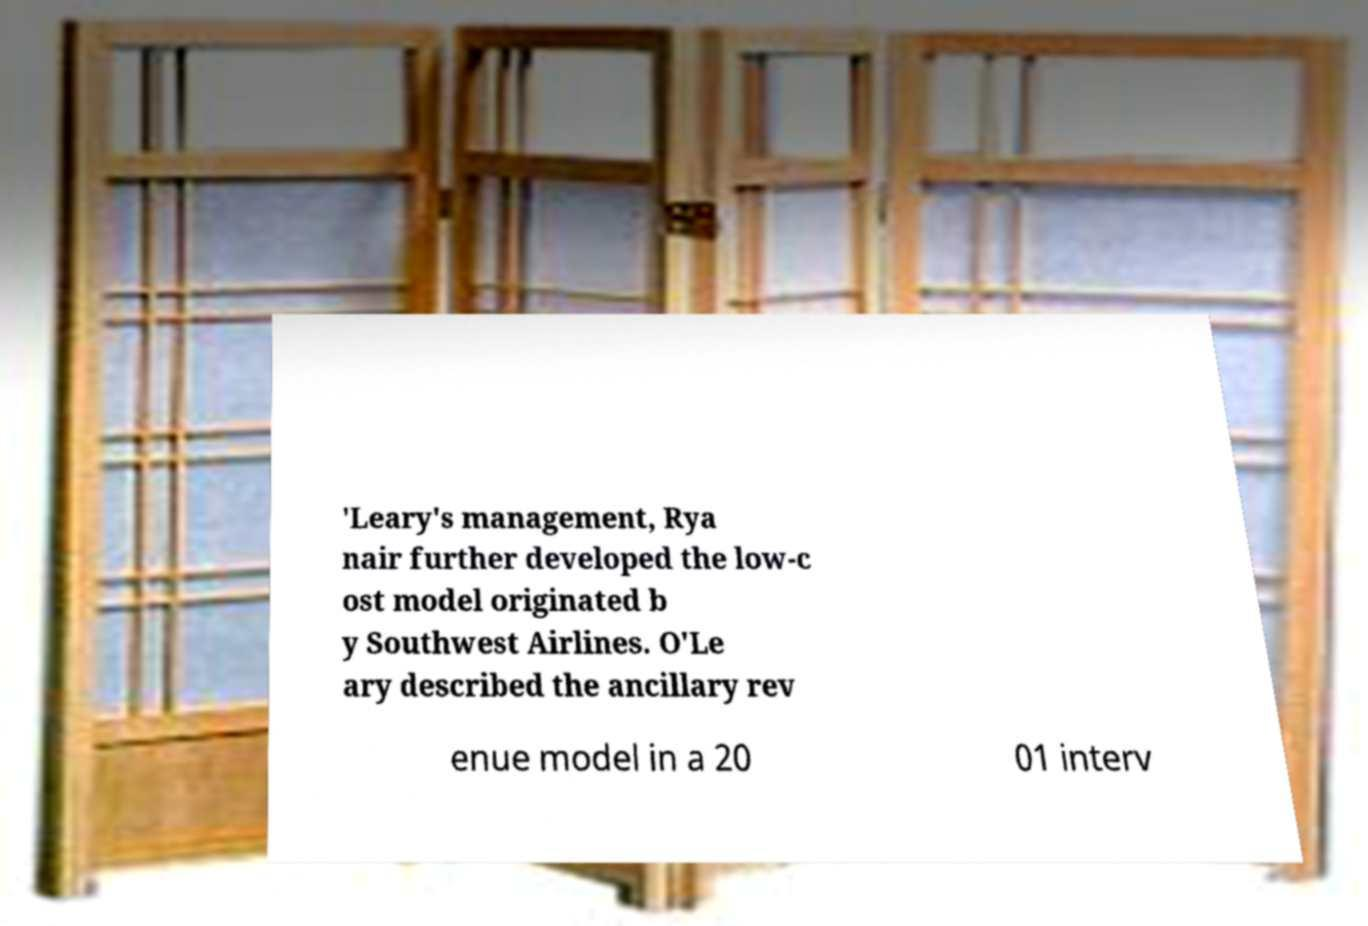What messages or text are displayed in this image? I need them in a readable, typed format. 'Leary's management, Rya nair further developed the low-c ost model originated b y Southwest Airlines. O'Le ary described the ancillary rev enue model in a 20 01 interv 